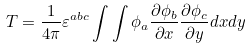<formula> <loc_0><loc_0><loc_500><loc_500>T = \frac { 1 } { 4 \pi } \varepsilon ^ { a b c } \int \int \phi _ { a } \frac { \partial \phi _ { b } } { \partial x } \frac { \partial \phi _ { c } } { \partial y } d x d y</formula> 